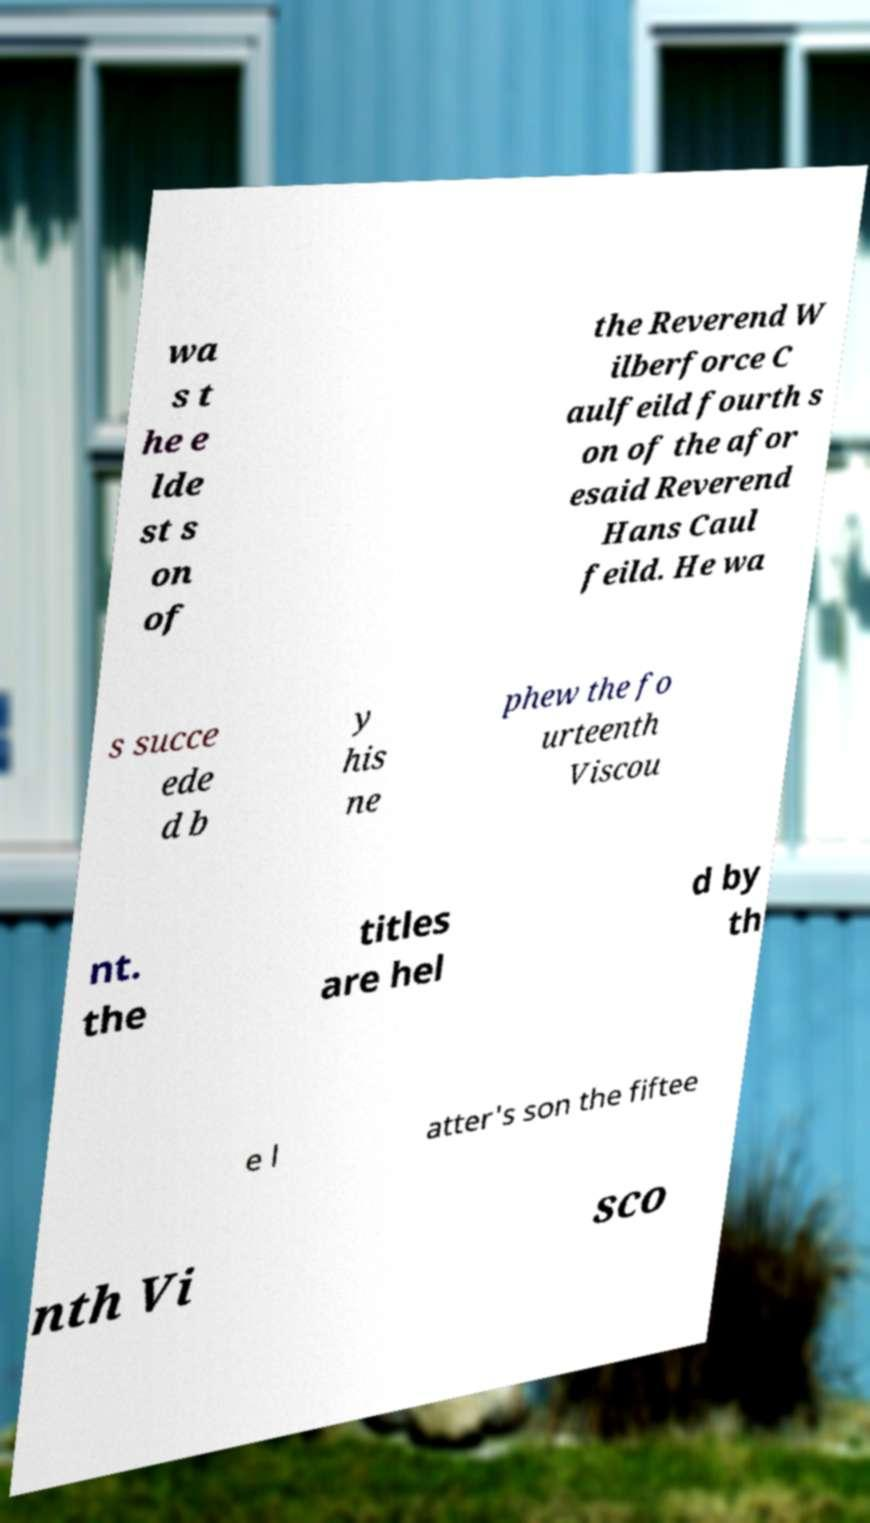Could you assist in decoding the text presented in this image and type it out clearly? wa s t he e lde st s on of the Reverend W ilberforce C aulfeild fourth s on of the afor esaid Reverend Hans Caul feild. He wa s succe ede d b y his ne phew the fo urteenth Viscou nt. the titles are hel d by th e l atter's son the fiftee nth Vi sco 